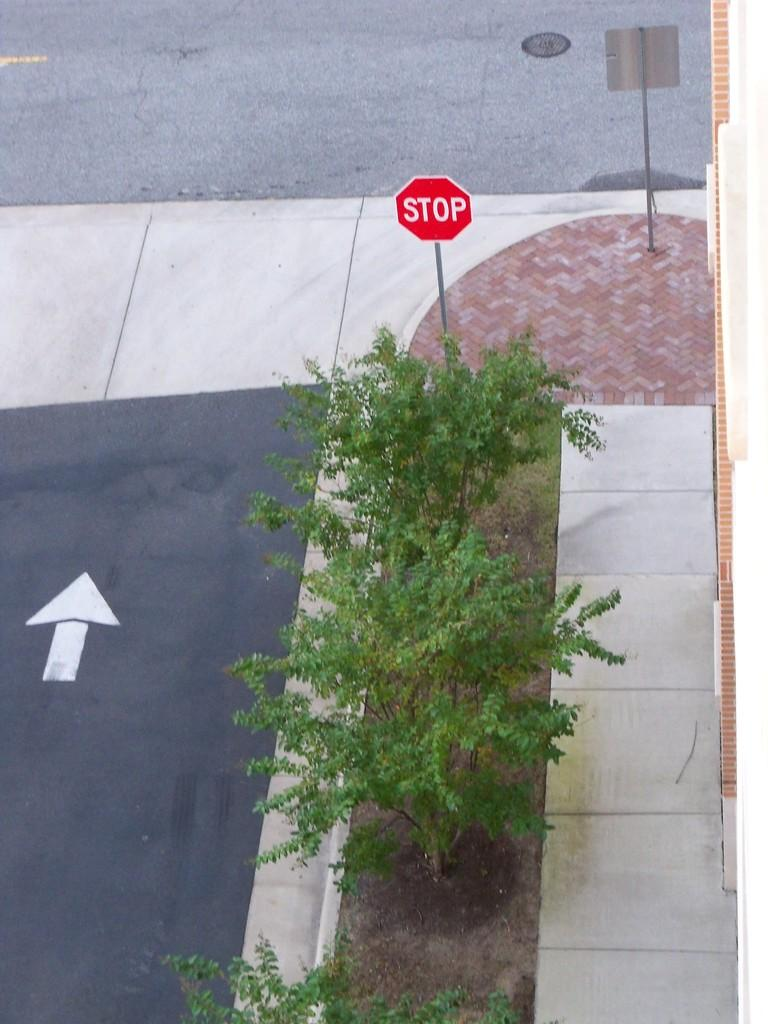Provide a one-sentence caption for the provided image. Road that contains a upward arrow and a stop sign on the sidewalk. 